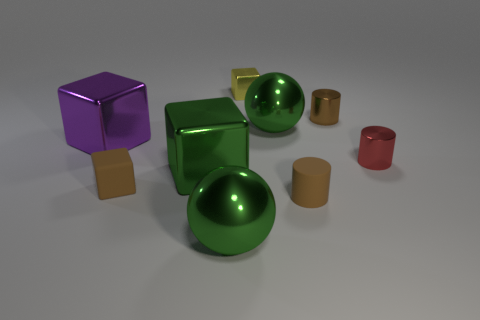Subtract 1 cubes. How many cubes are left? 3 Subtract all red cubes. Subtract all gray balls. How many cubes are left? 4 Add 1 blue matte cylinders. How many objects exist? 10 Subtract all cylinders. How many objects are left? 6 Subtract 0 yellow balls. How many objects are left? 9 Subtract all big red matte things. Subtract all large purple shiny cubes. How many objects are left? 8 Add 9 large purple metallic blocks. How many large purple metallic blocks are left? 10 Add 6 big objects. How many big objects exist? 10 